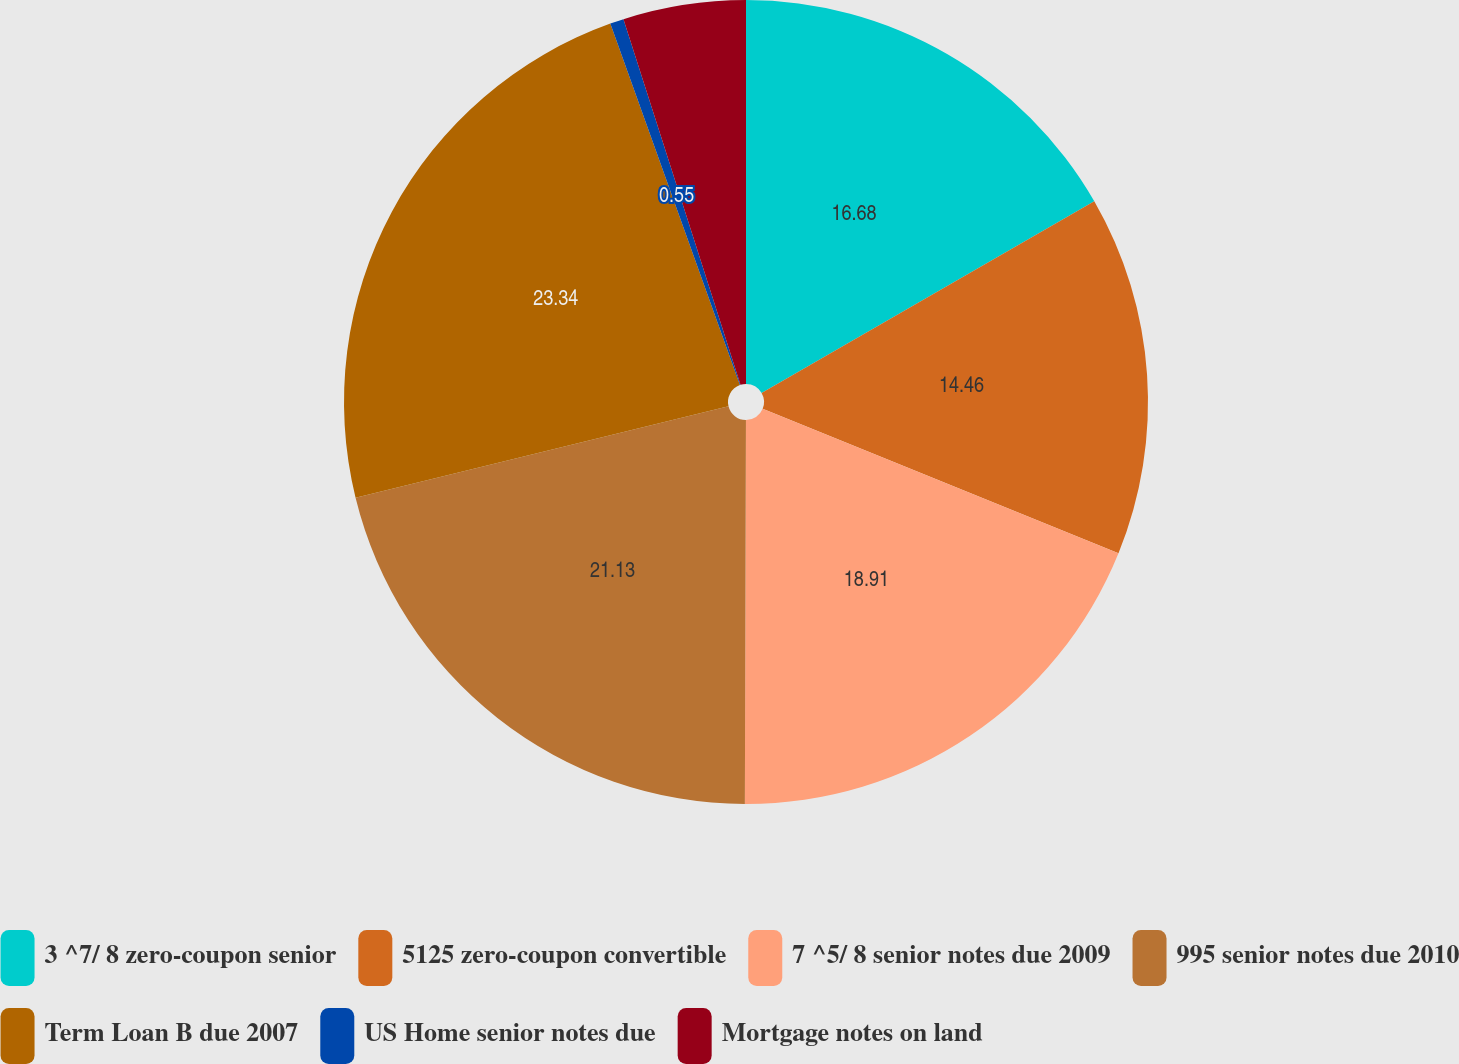Convert chart to OTSL. <chart><loc_0><loc_0><loc_500><loc_500><pie_chart><fcel>3 ^7/ 8 zero-coupon senior<fcel>5125 zero-coupon convertible<fcel>7 ^5/ 8 senior notes due 2009<fcel>995 senior notes due 2010<fcel>Term Loan B due 2007<fcel>US Home senior notes due<fcel>Mortgage notes on land<nl><fcel>16.68%<fcel>14.46%<fcel>18.91%<fcel>21.13%<fcel>23.35%<fcel>0.55%<fcel>4.93%<nl></chart> 